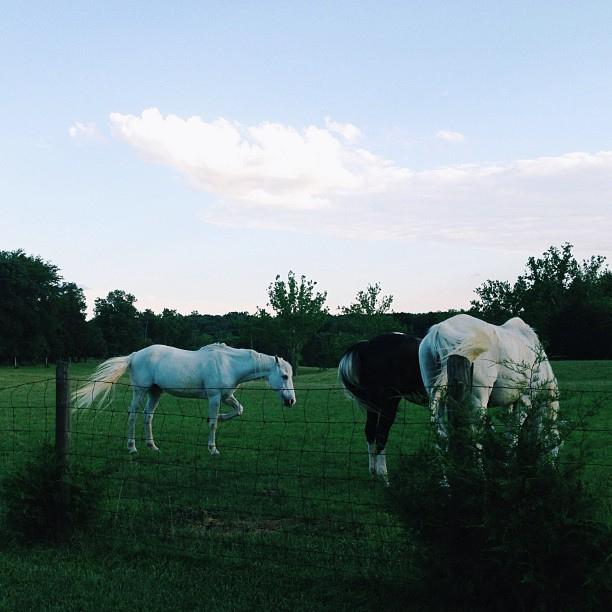How many horses have their hind parts facing the camera?
Give a very brief answer. 2. What kind of animals are shown?
Short answer required. Horses. What is barricading the horses?
Concise answer only. Fence. 